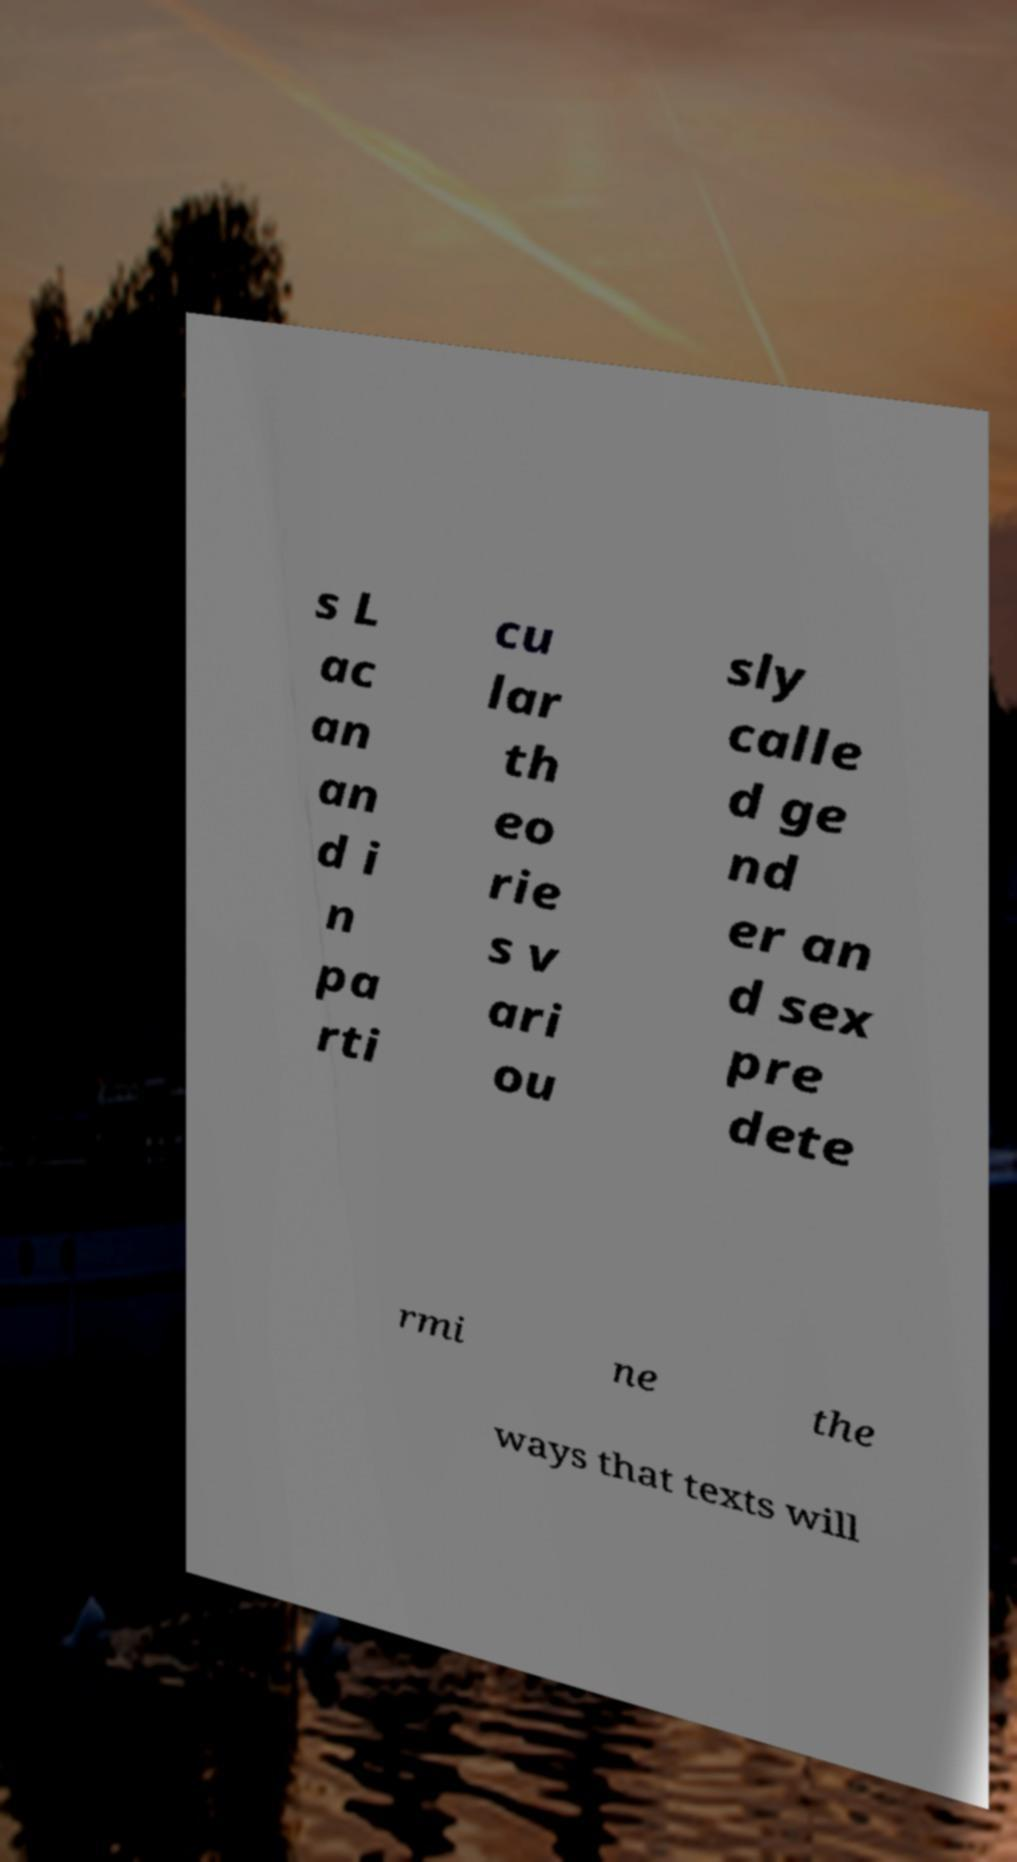What messages or text are displayed in this image? I need them in a readable, typed format. s L ac an an d i n pa rti cu lar th eo rie s v ari ou sly calle d ge nd er an d sex pre dete rmi ne the ways that texts will 